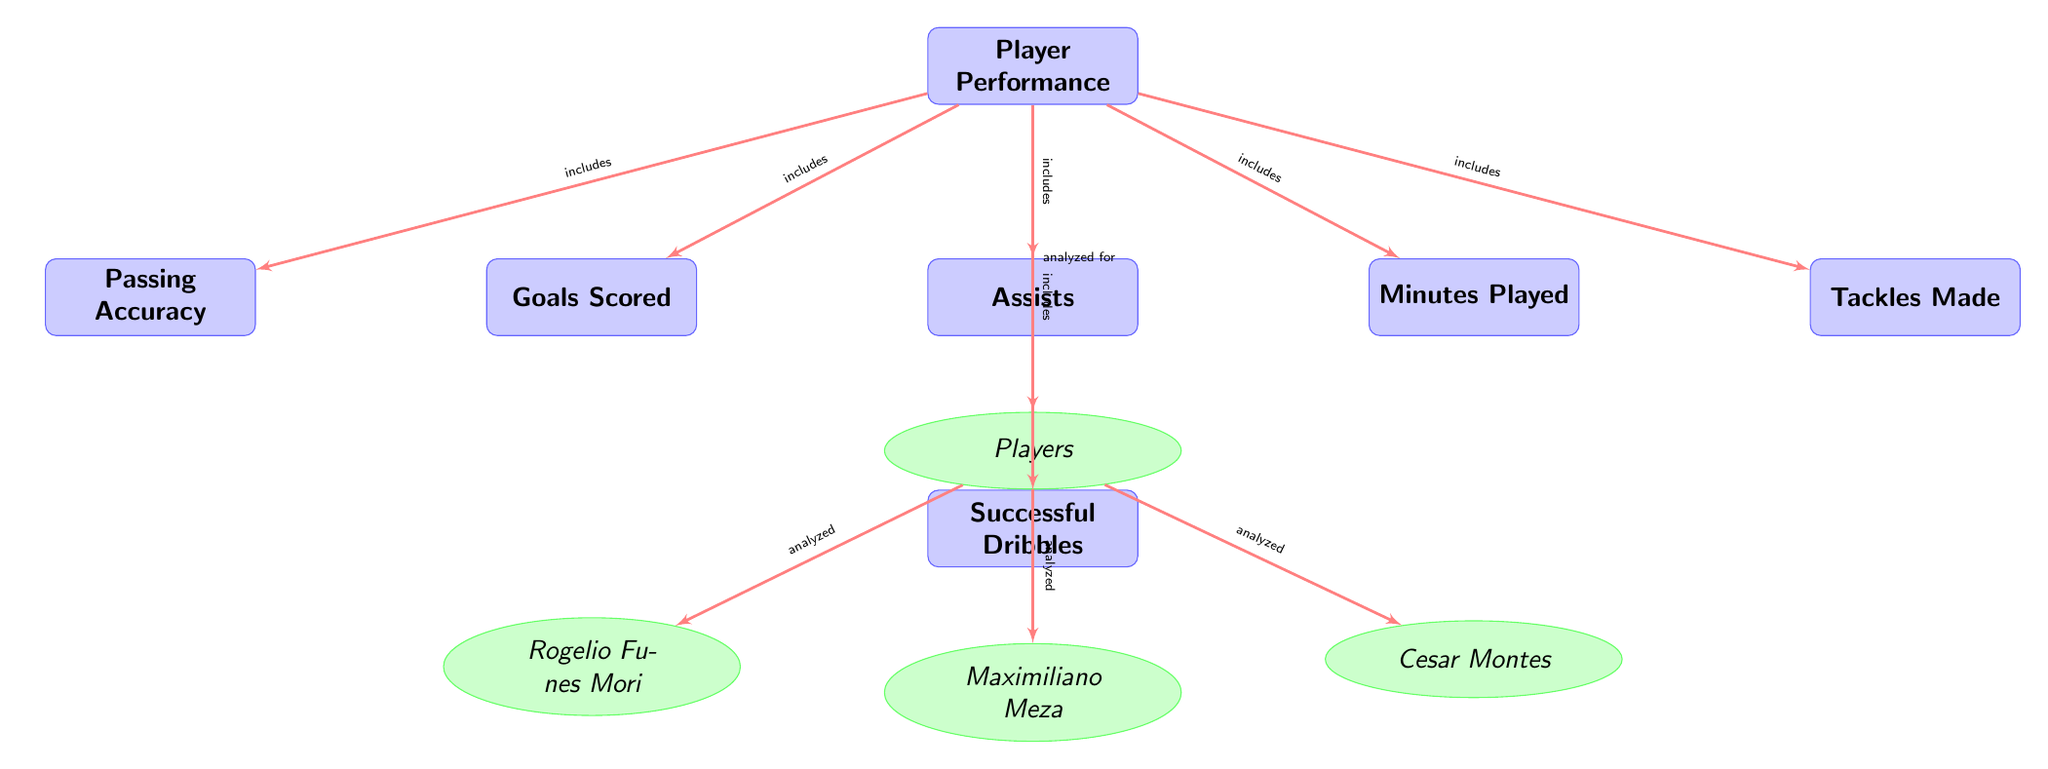What nodes are analyzed for player performance? The diagram shows that the nodes "Goals Scored," "Assists," "Minutes Played," "Passing Accuracy," "Tackles Made," and "Successful Dribbles" are all connected to the main node "Player Performance" with the label "includes."
Answer: Goals Scored, Assists, Minutes Played, Passing Accuracy, Tackles Made, Successful Dribbles How many players are listed in the diagram? The diagram includes three player nodes connected to the "Players" node, which are "Rogelio Funes Mori," "Maximiliano Meza," and "Cesar Montes." Hence, a simple count of these nodes gives the total number of players.
Answer: 3 What type of node is "Passing Accuracy"? Looking at the structure of the diagram, "Passing Accuracy" is categorized as a main node that is rectangular and includes specific statistics related to player performance.
Answer: Main node Which players are analyzed according to this diagram? The player nodes connected to the "Players" node include "Rogelio Funes Mori," "Maximiliano Meza," and "Cesar Montes." These are the specific players analyzed in the context of player performance.
Answer: Rogelio Funes Mori, Maximiliano Meza, Cesar Montes What is the relationship between "Players" and "Player Performance"? The diagram identifies that the "Players" node is directly connected to the "Player Performance" node with an edge labeled "analyzed for," indicating that the individual player statistics are analyzed in the context of overall performance.
Answer: Analyzed for 